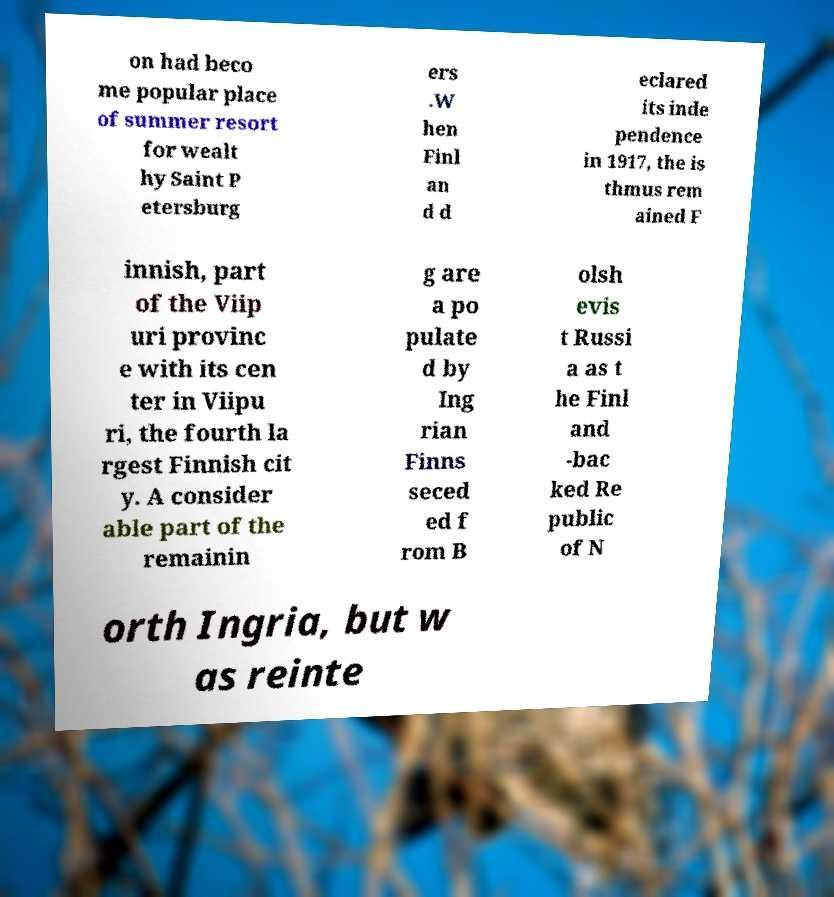Please identify and transcribe the text found in this image. on had beco me popular place of summer resort for wealt hy Saint P etersburg ers .W hen Finl an d d eclared its inde pendence in 1917, the is thmus rem ained F innish, part of the Viip uri provinc e with its cen ter in Viipu ri, the fourth la rgest Finnish cit y. A consider able part of the remainin g are a po pulate d by Ing rian Finns seced ed f rom B olsh evis t Russi a as t he Finl and -bac ked Re public of N orth Ingria, but w as reinte 